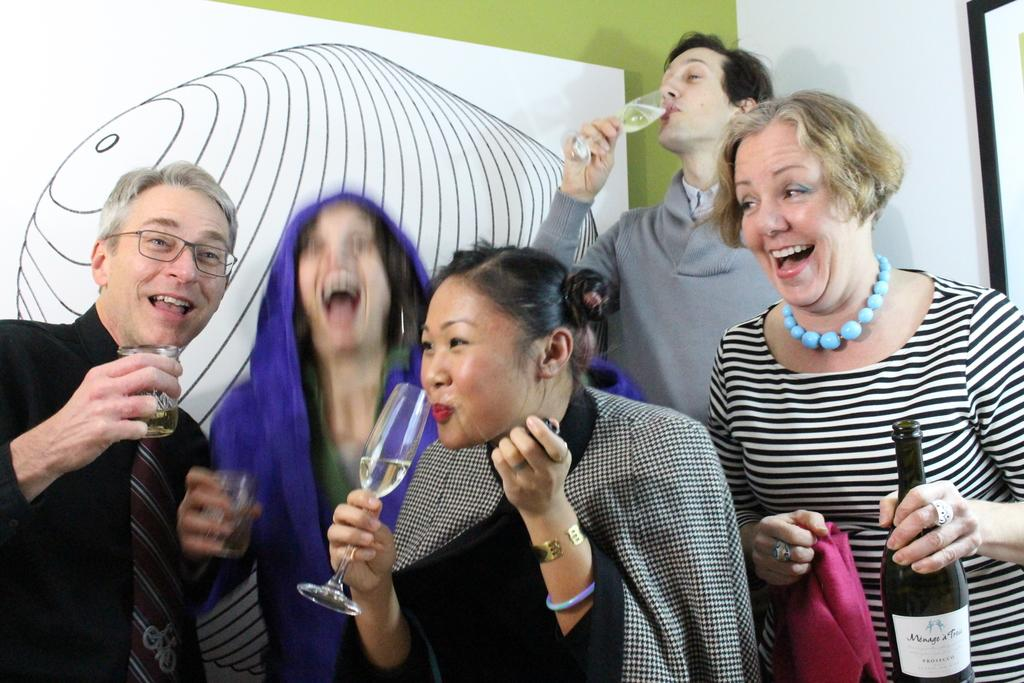How many people are present in the image? There are five people in the image. What is one person doing with an object? One person is holding an object. What can be seen on the drawing board in the image? Unfortunately, the facts provided do not give any information about the drawing board. What activity is one person engaged in? One person is drinking. What type of chin is visible on the person holding the object? There is no mention of a chin in the image, and the person holding the object is not described in detail. 